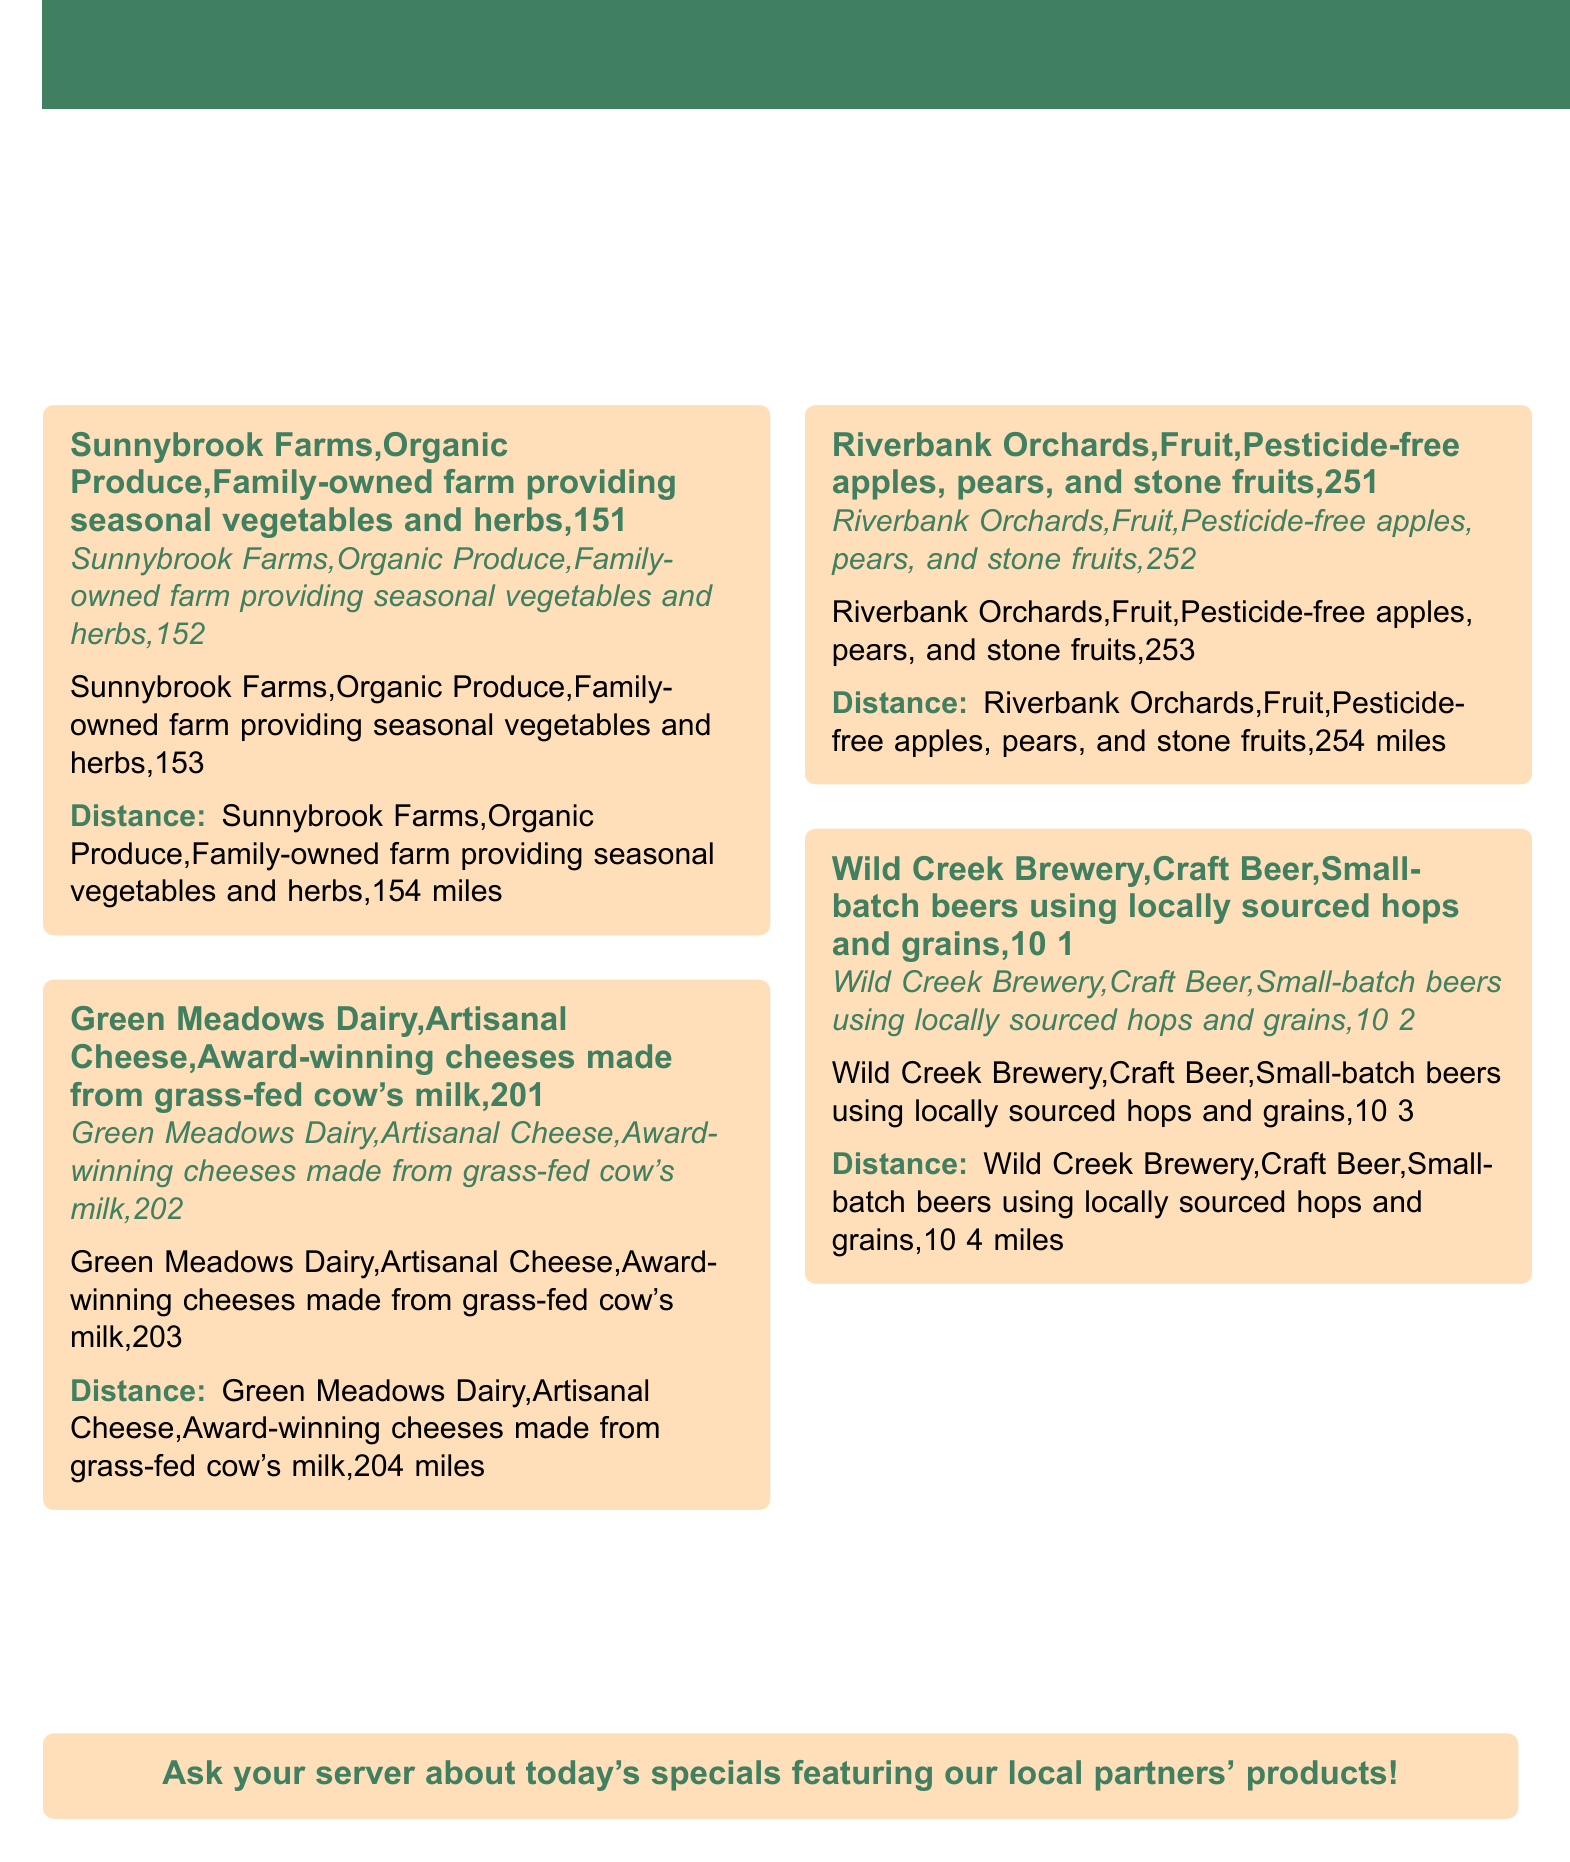What is the name of the family-owned farm? The document lists "Sunnybrook Farms" as the family-owned farm providing seasonal vegetables and herbs.
Answer: Sunnybrook Farms Who produces artisanal cheese? "Green Meadows Dairy" is mentioned as the producer of award-winning cheeses made from grass-fed cow's milk.
Answer: Green Meadows Dairy What type of fruit does Riverbank Orchards provide? The document specifies that Riverbank Orchards offers pesticide-free apples, pears, and stone fruits.
Answer: Pesticide-free apples, pears, and stone fruits How far is Wild Creek Brewery from the restaurant? The distance mentioned for Wild Creek Brewery is 10 miles.
Answer: 10 miles What is emphasized by the partnerships with local suppliers? The partnerships emphasize the restaurant's commitment to sustainability and the use of high-quality ingredients.
Answer: Sustainability and high-quality ingredients What is the main color used in the document's design? The document uses the specified color identified as "maincolor" for the title and important elements.
Answer: Main color What does the restaurant encourage customers to do regarding the specials? The document states to "Ask your server about today's specials featuring our local partners' products!"
Answer: Ask your server about today's specials How many local partners are showcased in the document? The document showcases four local partners: Sunnybrook Farms, Green Meadows Dairy, Riverbank Orchards, and Wild Creek Brewery.
Answer: Four local partners 